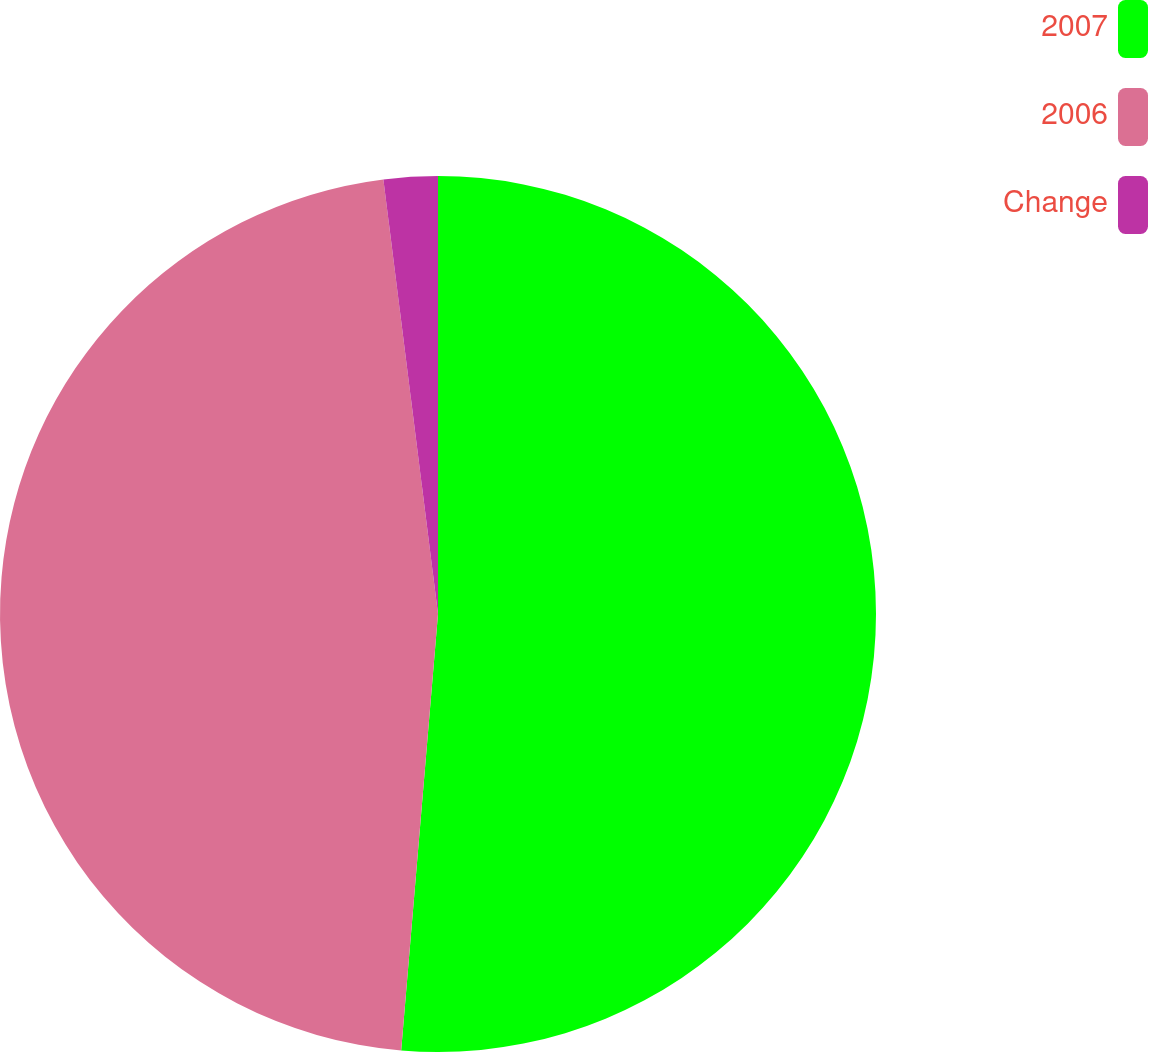<chart> <loc_0><loc_0><loc_500><loc_500><pie_chart><fcel>2007<fcel>2006<fcel>Change<nl><fcel>51.34%<fcel>46.67%<fcel>1.99%<nl></chart> 